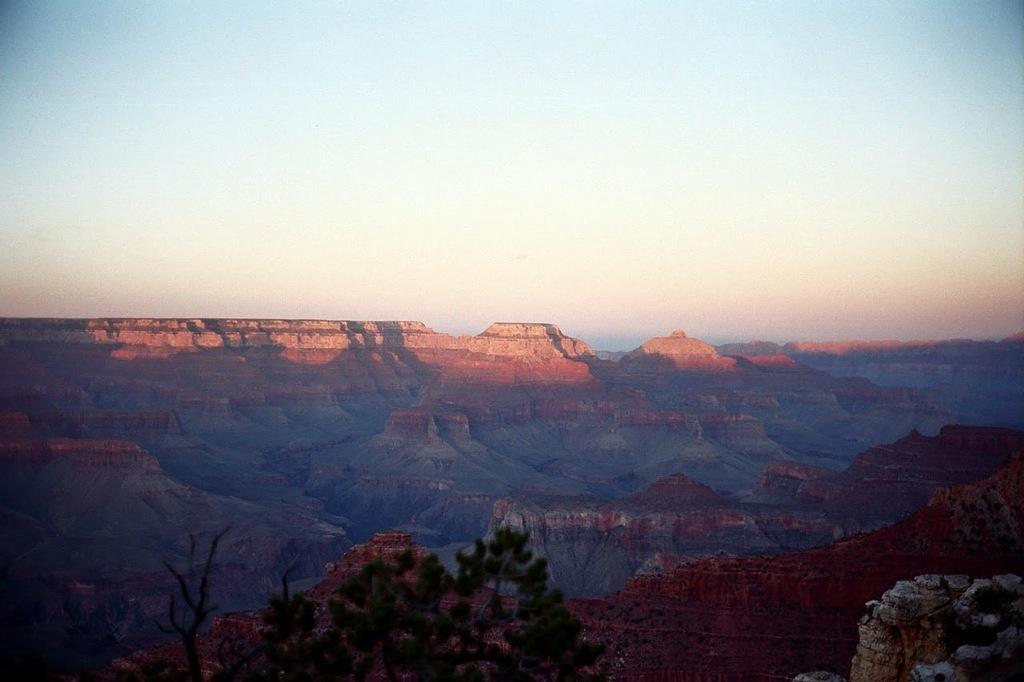How would you summarize this image in a sentence or two? In this picture we can see hills, leaves and branches. In the background of the image we can see the sky. 